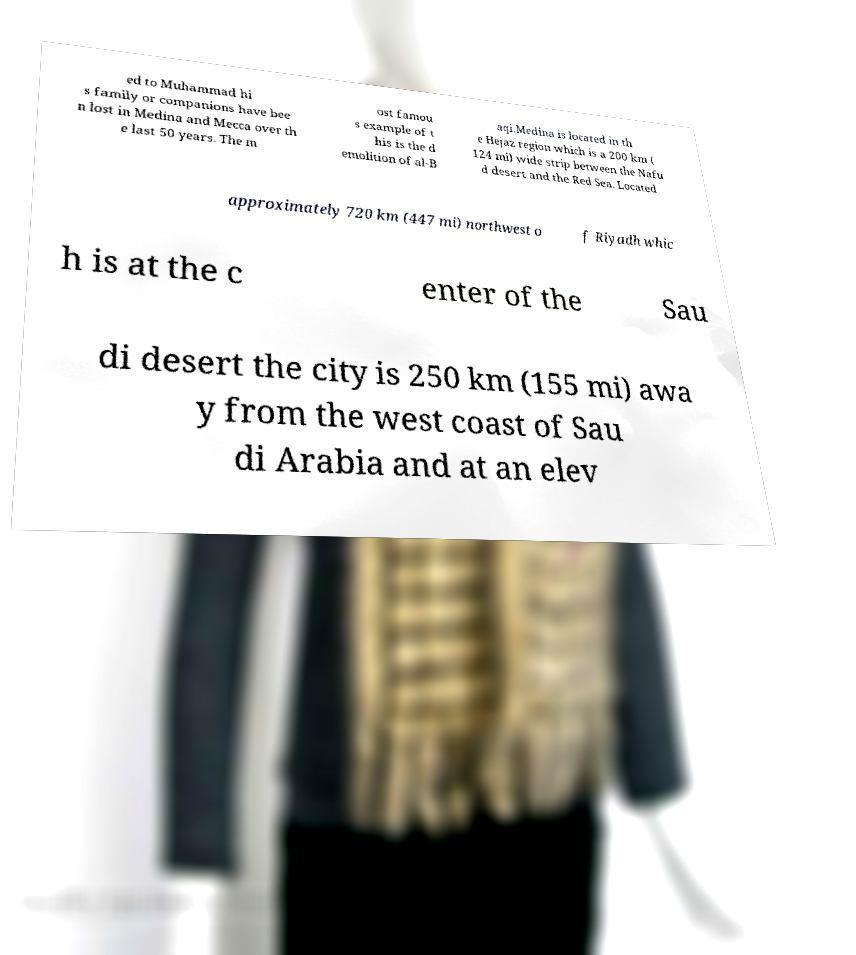There's text embedded in this image that I need extracted. Can you transcribe it verbatim? ed to Muhammad hi s family or companions have bee n lost in Medina and Mecca over th e last 50 years. The m ost famou s example of t his is the d emolition of al-B aqi.Medina is located in th e Hejaz region which is a 200 km ( 124 mi) wide strip between the Nafu d desert and the Red Sea. Located approximately 720 km (447 mi) northwest o f Riyadh whic h is at the c enter of the Sau di desert the city is 250 km (155 mi) awa y from the west coast of Sau di Arabia and at an elev 